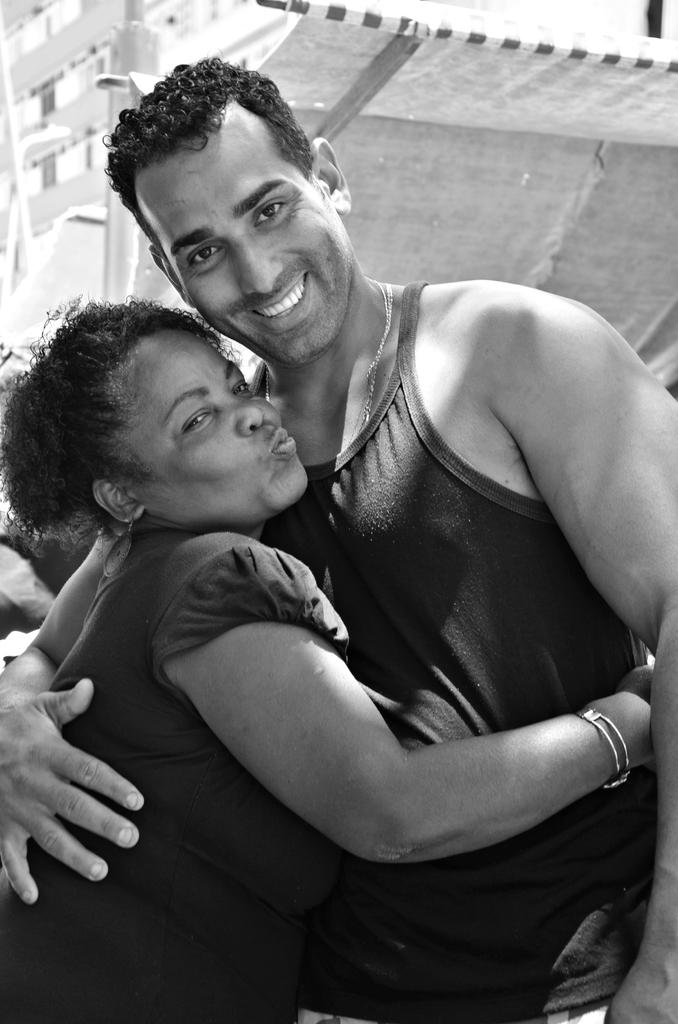What is the color scheme of the image? The image is black and white. How many people are in the foreground of the image? There are two persons in the foreground. What is the facial expression of the persons in the image? The persons are smiling. What surface are the persons standing on in the image? The persons are standing on the ground. What can be seen in the background of the image? There is a roof and a building visible in the background. What type of locket is the person holding in the image? There is no locket present in the image. Can you tell me how many pets are visible in the image? There are no pets visible in the image. 